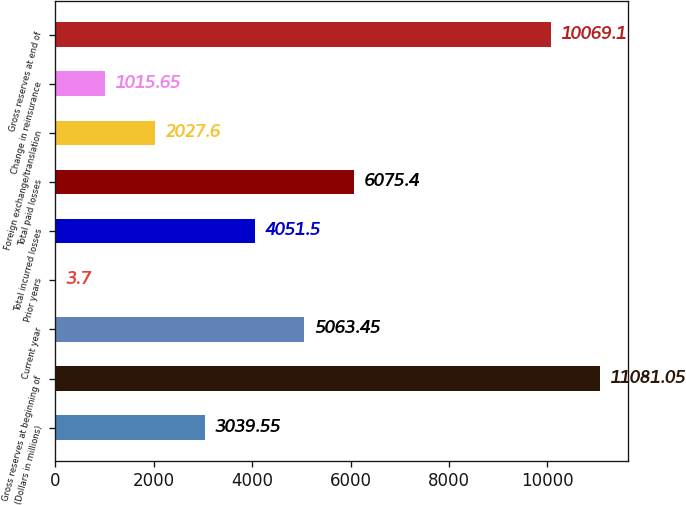<chart> <loc_0><loc_0><loc_500><loc_500><bar_chart><fcel>(Dollars in millions)<fcel>Gross reserves at beginning of<fcel>Current year<fcel>Prior years<fcel>Total incurred losses<fcel>Total paid losses<fcel>Foreign exchange/translation<fcel>Change in reinsurance<fcel>Gross reserves at end of<nl><fcel>3039.55<fcel>11081<fcel>5063.45<fcel>3.7<fcel>4051.5<fcel>6075.4<fcel>2027.6<fcel>1015.65<fcel>10069.1<nl></chart> 